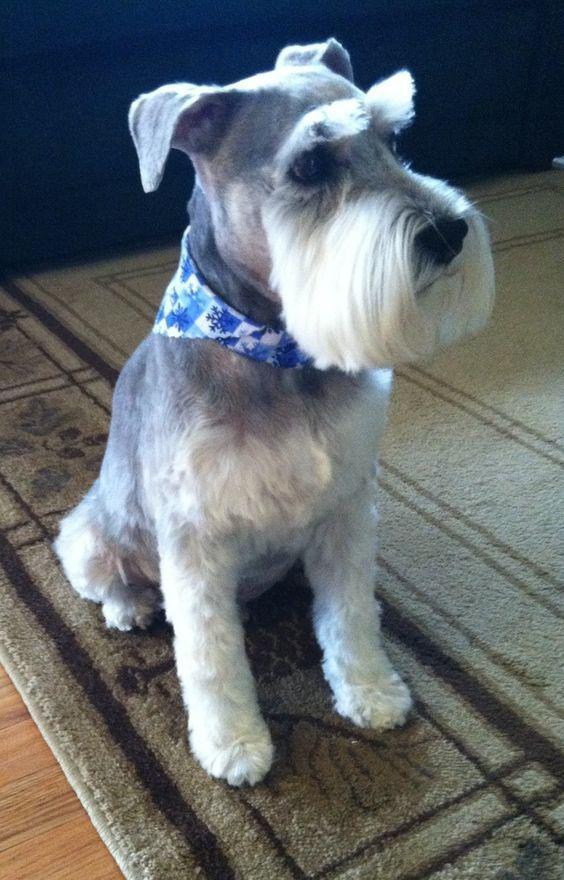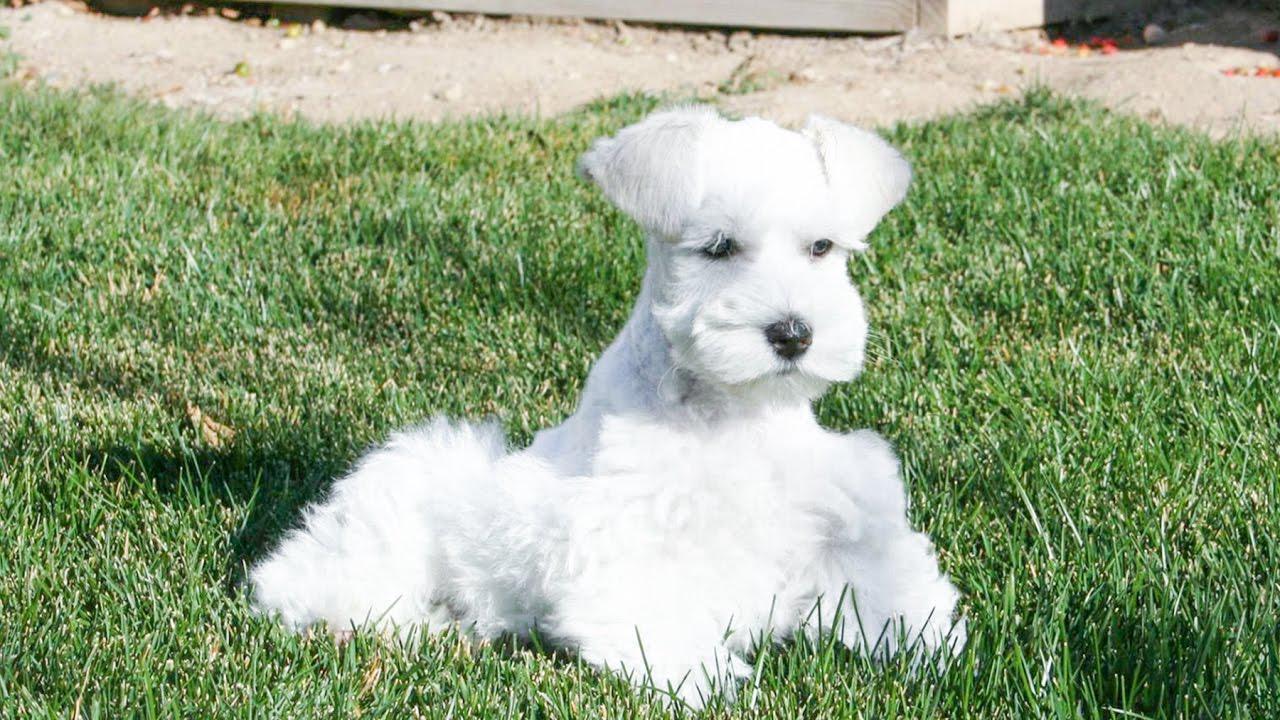The first image is the image on the left, the second image is the image on the right. For the images shown, is this caption "An image features a schnauzer sitting upright on nongrass surface with head turned somewhat rightward." true? Answer yes or no. Yes. The first image is the image on the left, the second image is the image on the right. For the images shown, is this caption "There is a dog on grass in one of the iamges" true? Answer yes or no. Yes. 